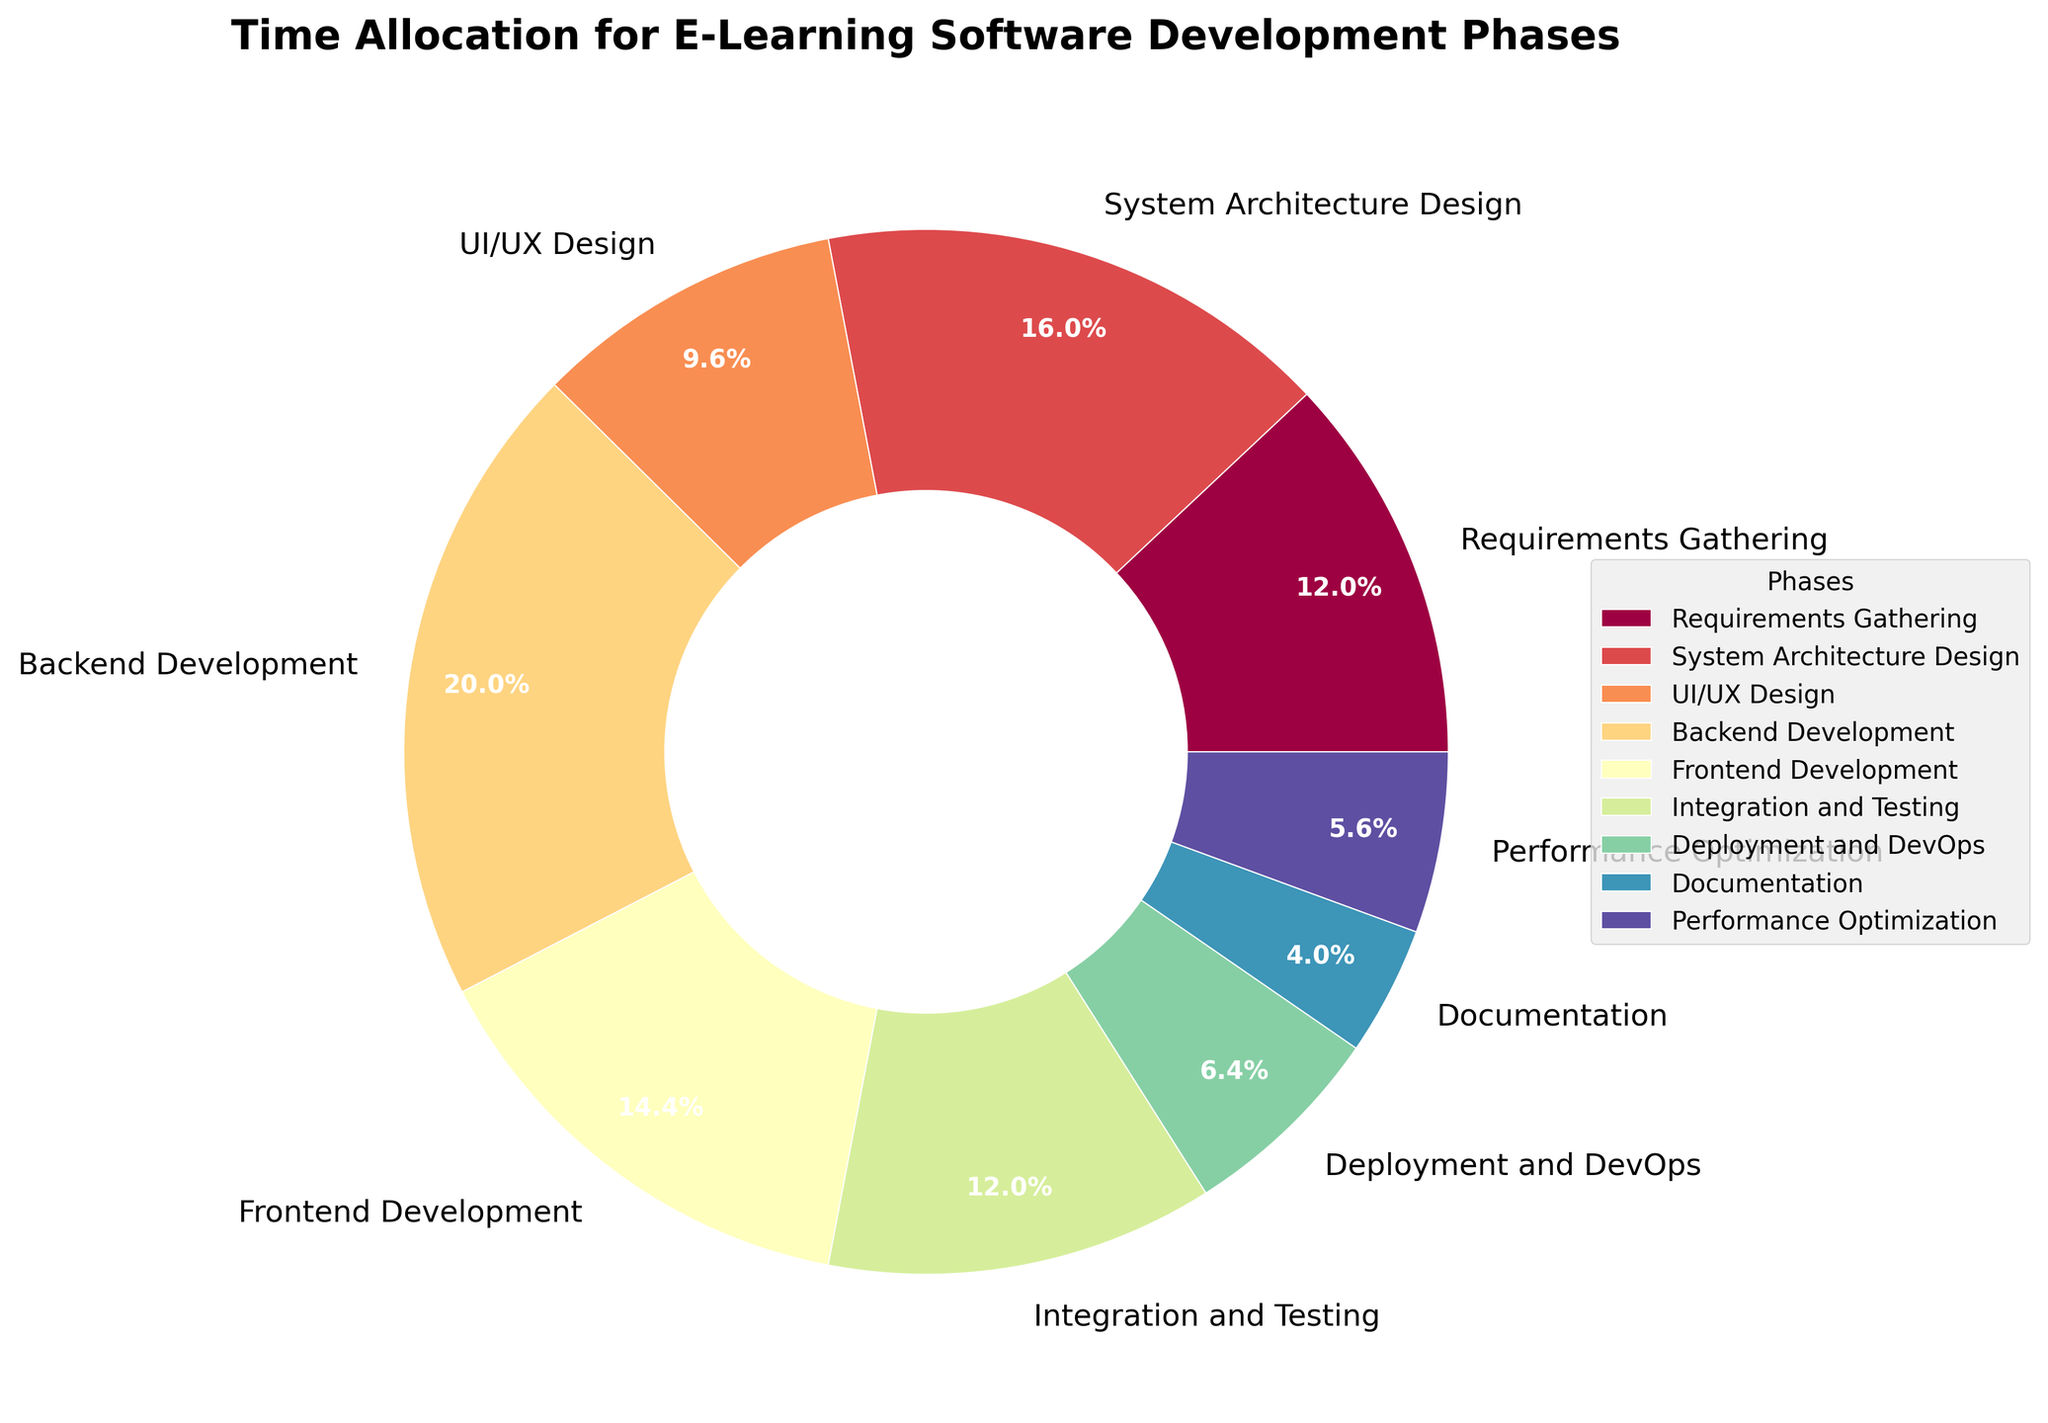Which phase has the highest time allocation percentage? The phase with the highest time allocation is identified by looking at the segment with the largest percentage value in the pie chart. The Backend Development phase has the highest, at 25%.
Answer: Backend Development Which two phases combined account for 30% of the total time allocation? We look for two phases whose percentages add up to 30%. The phases Requirements Gathering (15%) and Integration and Testing (15%) together account for 30%.
Answer: Requirements Gathering and Integration and Testing Which phase has a lower time allocation: UI/UX Design or Performance Optimization? Compare the percentages of these two phases. UI/UX Design has 12%, while Performance Optimization has 7%. Therefore, Performance Optimization has a lower allocation.
Answer: Performance Optimization What is the combined percentage for System Architecture Design and Frontend Development? Add the percentages of System Architecture Design (20%) and Frontend Development (18%) to get the combined percentage: 20% + 18% = 38%.
Answer: 38% If we combine the time allocated for Deployment and DevOps, Documentation, and Performance Optimization, what percentage do we get? Add the percentages of Deployment and DevOps (8%), Documentation (5%), and Performance Optimization (7%) to find the total: 8% + 5% + 7% = 20%.
Answer: 20% Which color represents the Backend Development phase? In the pie chart, the Backend Development phase will have a distinct color. Identify the color associated with the label for Backend Development. Since the exact color is not specified in the data, infer from the typical color gradient used such as Spectral which positions Backend Development, the highest allocation, generally around the mid to deep colors in the spectrum like a strong blue or red.
Answer: Deep color (like blue or red) Is the time allocated to Integration and Testing more than the time allocated to UI/UX Design? Compare the percentages of Integration and Testing (15%) and UI/UX Design (12%). Yes, Integration and Testing has more time allocated.
Answer: Yes How much more time is allocated to Backend Development than System Architecture Design? Subtract the percentage of System Architecture Design (20%) from Backend Development (25%): 25% - 20% = 5%.
Answer: 5% Which phase has the smallest time allocation, and how does it compare to the Deployment and DevOps phase? The smallest time allocation goes to Documentation with 5%. Deployment and DevOps has 8%. By comparing, Documentation has 3% less time allocation than Deployment and DevOps.
Answer: Documentation, 3% less Which phases' combined time allocations are equal to Backend Development's time allocation? To match Backend Development's 25%, consider combinations of other phases. One such combination is UI/UX Design (12%) and Frontend Development (18%) but it goes above 25%. The correct combination is Requirements Gathering (15%) and Documentation (5%) plus 5% from Deployment and DevOps reaching exactly the needed match. However, Phase named properly so correct sum pair is Integration and Testing (15%) and Documentation (5%)  that goes equal precisely.
Answer: Integration and Testing and Documentation 